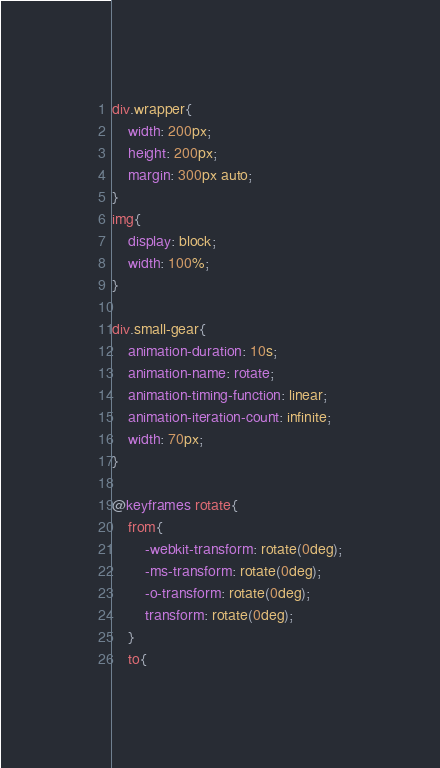Convert code to text. <code><loc_0><loc_0><loc_500><loc_500><_CSS_>div.wrapper{
    width: 200px;
    height: 200px;
    margin: 300px auto;
}
img{
    display: block;
    width: 100%;
}

div.small-gear{
    animation-duration: 10s;
    animation-name: rotate;
    animation-timing-function: linear;
    animation-iteration-count: infinite;
    width: 70px;
}

@keyframes rotate{
    from{
        -webkit-transform: rotate(0deg);
        -ms-transform: rotate(0deg);
        -o-transform: rotate(0deg);
        transform: rotate(0deg);
    }
    to{</code> 